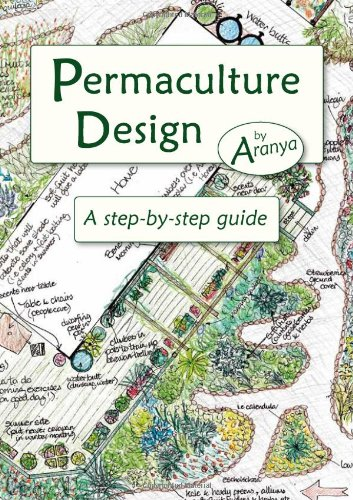What are some key elements shown in the cover illustration of this book? The cover features a rich tapestry of a permaculture garden, showcasing elements like varied plant species, water bodies, and integrated living spaces, all arranged to mimic natural ecosystems and promote biodiversity. 